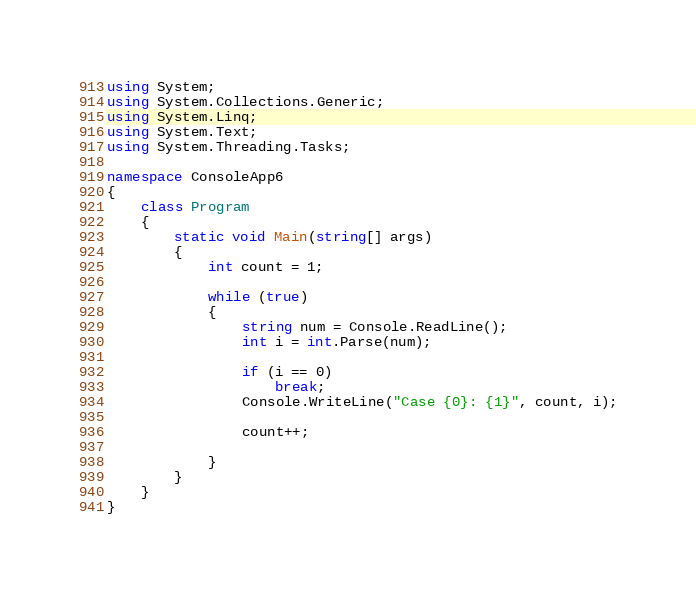<code> <loc_0><loc_0><loc_500><loc_500><_C#_>using System;
using System.Collections.Generic;
using System.Linq;
using System.Text;
using System.Threading.Tasks;

namespace ConsoleApp6
{
	class Program
	{
		static void Main(string[] args)
		{
			int count = 1;

			while (true)
			{
				string num = Console.ReadLine();
				int i = int.Parse(num);
				
				if (i == 0)
					break;
				Console.WriteLine("Case {0}: {1}", count, i);

				count++;

			}
		}
	}
}

</code> 